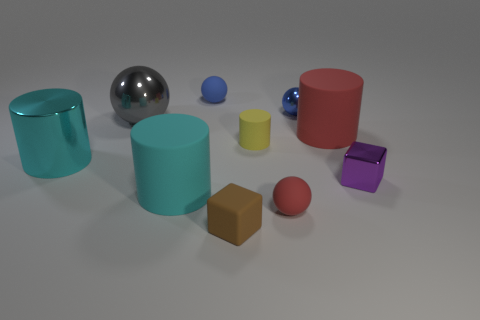Subtract 2 cubes. How many cubes are left? 0 Subtract all tiny red balls. How many balls are left? 3 Subtract all blue balls. How many balls are left? 2 Subtract 2 blue spheres. How many objects are left? 8 Subtract all balls. How many objects are left? 6 Subtract all purple cylinders. Subtract all cyan balls. How many cylinders are left? 4 Subtract all gray spheres. How many red cylinders are left? 1 Subtract all big cyan rubber cylinders. Subtract all tiny yellow metal cylinders. How many objects are left? 9 Add 1 large gray shiny objects. How many large gray shiny objects are left? 2 Add 8 large cyan metallic things. How many large cyan metallic things exist? 9 